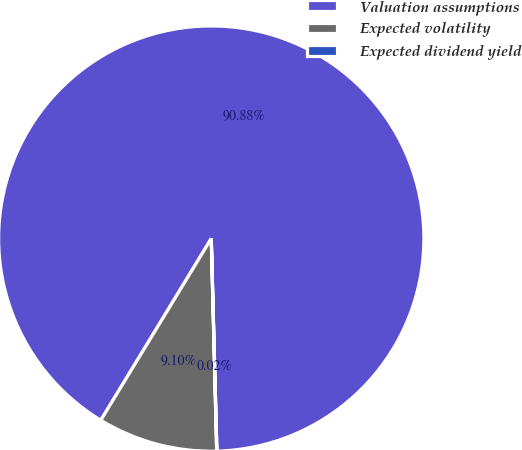Convert chart to OTSL. <chart><loc_0><loc_0><loc_500><loc_500><pie_chart><fcel>Valuation assumptions<fcel>Expected volatility<fcel>Expected dividend yield<nl><fcel>90.88%<fcel>9.1%<fcel>0.02%<nl></chart> 